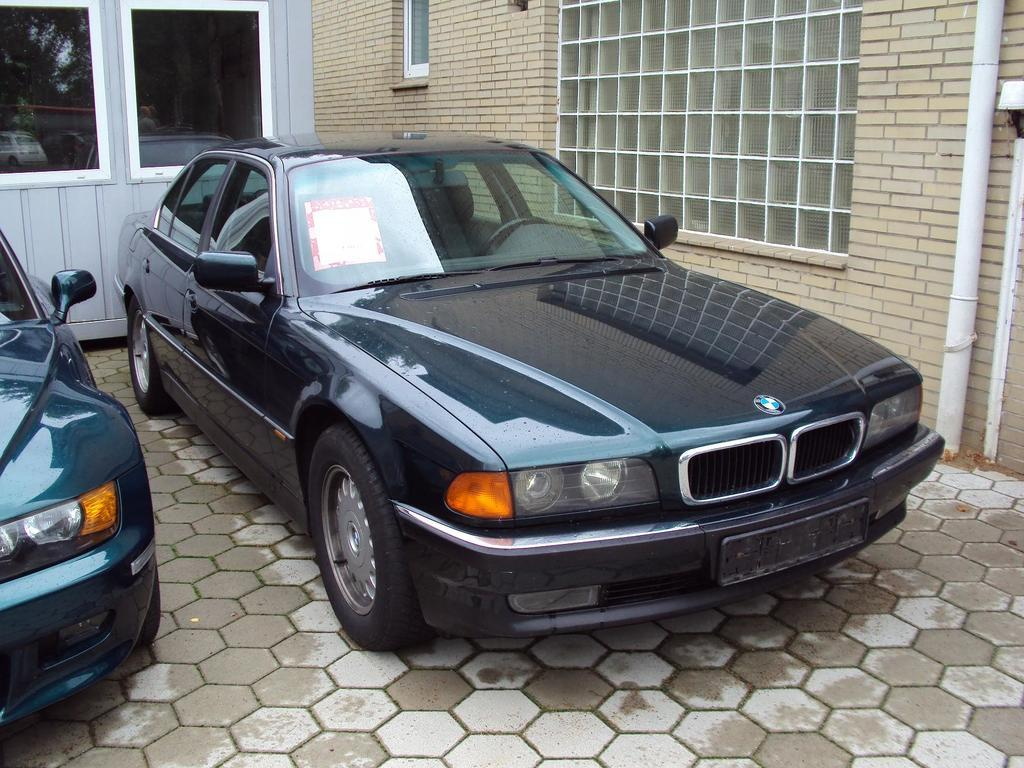How many cars are parked in the image? There are two cars parked on the floor in the image. What can be seen in the background of the image? There is a house, windows, and a pipe visible in the background of the image. Where is the table located in the image? There is no table present in the image. What type of coil is wrapped around the pipe in the image? There is no coil visible around the pipe in the image. 